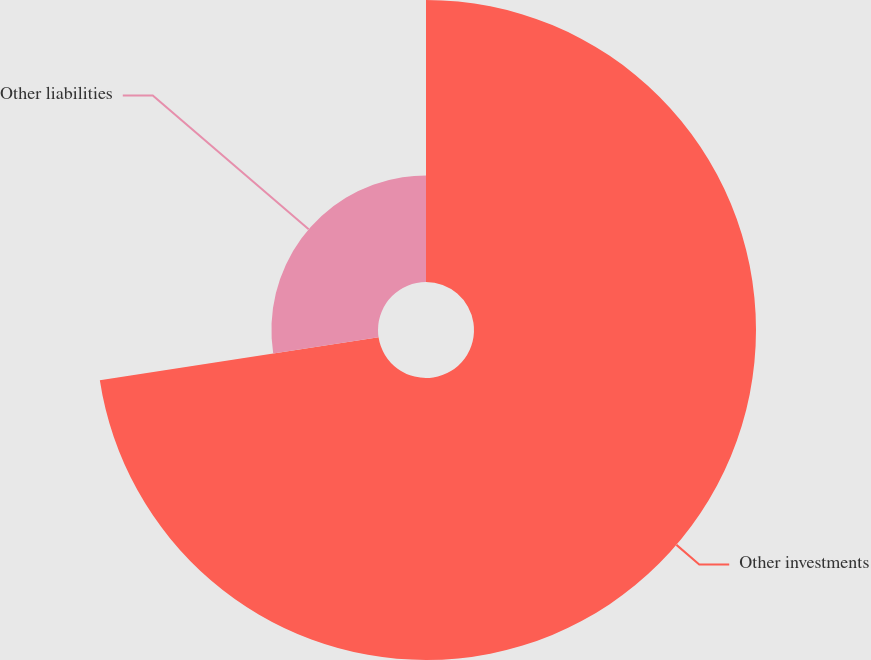<chart> <loc_0><loc_0><loc_500><loc_500><pie_chart><fcel>Other investments<fcel>Other liabilities<nl><fcel>72.57%<fcel>27.43%<nl></chart> 